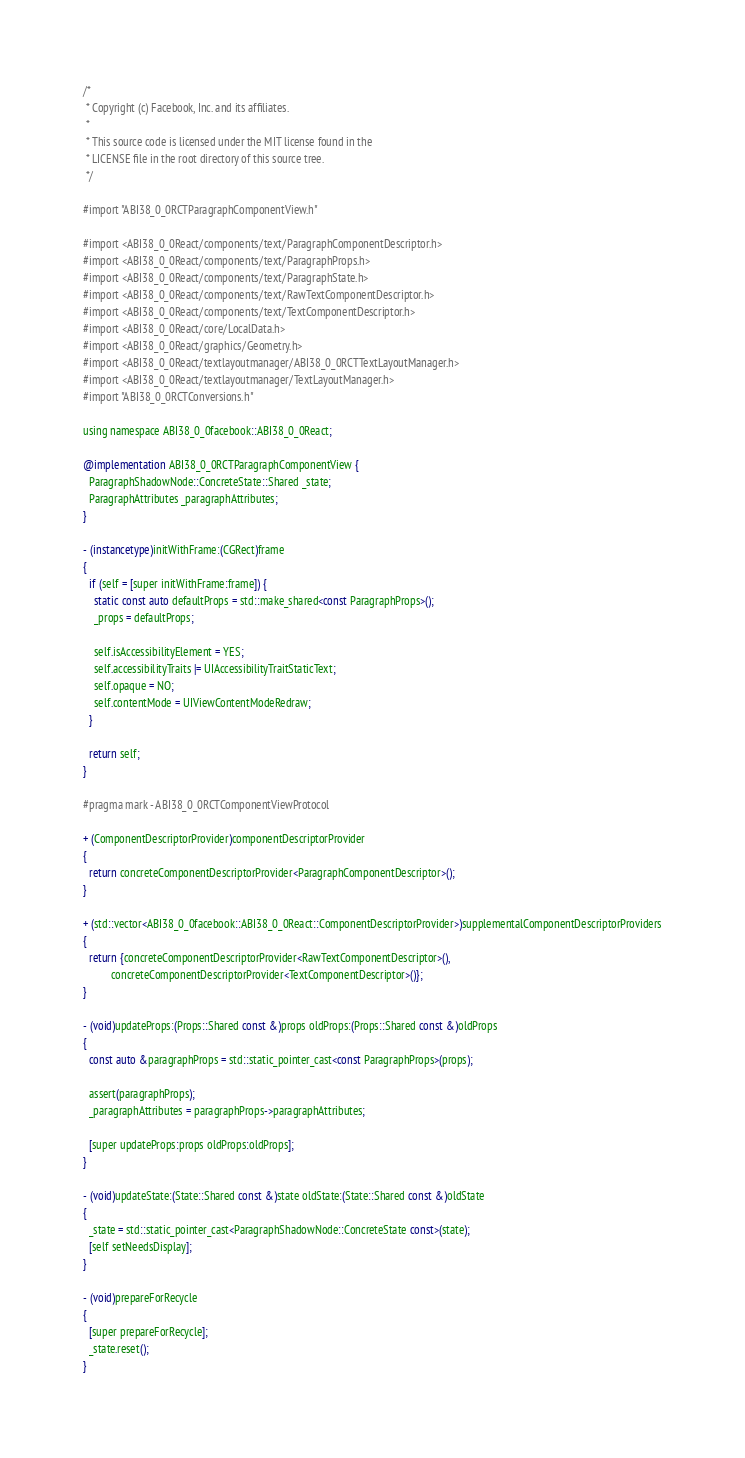Convert code to text. <code><loc_0><loc_0><loc_500><loc_500><_ObjectiveC_>/*
 * Copyright (c) Facebook, Inc. and its affiliates.
 *
 * This source code is licensed under the MIT license found in the
 * LICENSE file in the root directory of this source tree.
 */

#import "ABI38_0_0RCTParagraphComponentView.h"

#import <ABI38_0_0React/components/text/ParagraphComponentDescriptor.h>
#import <ABI38_0_0React/components/text/ParagraphProps.h>
#import <ABI38_0_0React/components/text/ParagraphState.h>
#import <ABI38_0_0React/components/text/RawTextComponentDescriptor.h>
#import <ABI38_0_0React/components/text/TextComponentDescriptor.h>
#import <ABI38_0_0React/core/LocalData.h>
#import <ABI38_0_0React/graphics/Geometry.h>
#import <ABI38_0_0React/textlayoutmanager/ABI38_0_0RCTTextLayoutManager.h>
#import <ABI38_0_0React/textlayoutmanager/TextLayoutManager.h>
#import "ABI38_0_0RCTConversions.h"

using namespace ABI38_0_0facebook::ABI38_0_0React;

@implementation ABI38_0_0RCTParagraphComponentView {
  ParagraphShadowNode::ConcreteState::Shared _state;
  ParagraphAttributes _paragraphAttributes;
}

- (instancetype)initWithFrame:(CGRect)frame
{
  if (self = [super initWithFrame:frame]) {
    static const auto defaultProps = std::make_shared<const ParagraphProps>();
    _props = defaultProps;

    self.isAccessibilityElement = YES;
    self.accessibilityTraits |= UIAccessibilityTraitStaticText;
    self.opaque = NO;
    self.contentMode = UIViewContentModeRedraw;
  }

  return self;
}

#pragma mark - ABI38_0_0RCTComponentViewProtocol

+ (ComponentDescriptorProvider)componentDescriptorProvider
{
  return concreteComponentDescriptorProvider<ParagraphComponentDescriptor>();
}

+ (std::vector<ABI38_0_0facebook::ABI38_0_0React::ComponentDescriptorProvider>)supplementalComponentDescriptorProviders
{
  return {concreteComponentDescriptorProvider<RawTextComponentDescriptor>(),
          concreteComponentDescriptorProvider<TextComponentDescriptor>()};
}

- (void)updateProps:(Props::Shared const &)props oldProps:(Props::Shared const &)oldProps
{
  const auto &paragraphProps = std::static_pointer_cast<const ParagraphProps>(props);

  assert(paragraphProps);
  _paragraphAttributes = paragraphProps->paragraphAttributes;

  [super updateProps:props oldProps:oldProps];
}

- (void)updateState:(State::Shared const &)state oldState:(State::Shared const &)oldState
{
  _state = std::static_pointer_cast<ParagraphShadowNode::ConcreteState const>(state);
  [self setNeedsDisplay];
}

- (void)prepareForRecycle
{
  [super prepareForRecycle];
  _state.reset();
}
</code> 